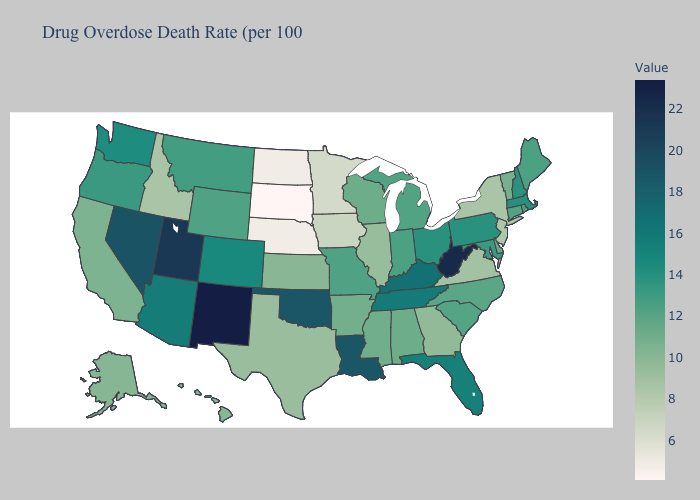Among the states that border Nevada , does Idaho have the lowest value?
Be succinct. Yes. Does West Virginia have a higher value than North Carolina?
Short answer required. Yes. Does the map have missing data?
Keep it brief. No. Does New Mexico have the highest value in the USA?
Quick response, please. Yes. Among the states that border Oregon , does Washington have the highest value?
Write a very short answer. No. Does Delaware have the highest value in the USA?
Short answer required. No. 